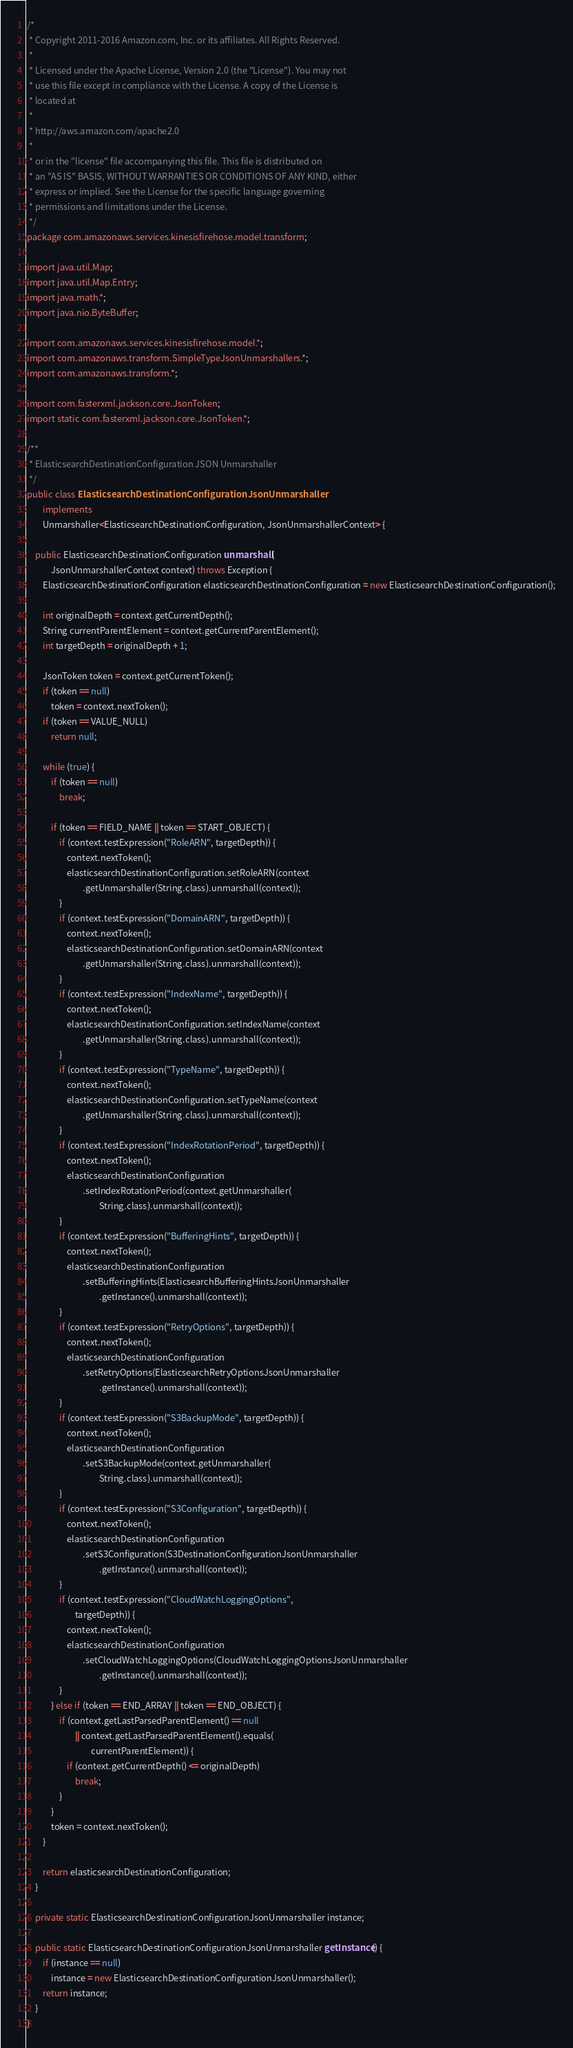Convert code to text. <code><loc_0><loc_0><loc_500><loc_500><_Java_>/*
 * Copyright 2011-2016 Amazon.com, Inc. or its affiliates. All Rights Reserved.
 * 
 * Licensed under the Apache License, Version 2.0 (the "License"). You may not
 * use this file except in compliance with the License. A copy of the License is
 * located at
 * 
 * http://aws.amazon.com/apache2.0
 * 
 * or in the "license" file accompanying this file. This file is distributed on
 * an "AS IS" BASIS, WITHOUT WARRANTIES OR CONDITIONS OF ANY KIND, either
 * express or implied. See the License for the specific language governing
 * permissions and limitations under the License.
 */
package com.amazonaws.services.kinesisfirehose.model.transform;

import java.util.Map;
import java.util.Map.Entry;
import java.math.*;
import java.nio.ByteBuffer;

import com.amazonaws.services.kinesisfirehose.model.*;
import com.amazonaws.transform.SimpleTypeJsonUnmarshallers.*;
import com.amazonaws.transform.*;

import com.fasterxml.jackson.core.JsonToken;
import static com.fasterxml.jackson.core.JsonToken.*;

/**
 * ElasticsearchDestinationConfiguration JSON Unmarshaller
 */
public class ElasticsearchDestinationConfigurationJsonUnmarshaller
        implements
        Unmarshaller<ElasticsearchDestinationConfiguration, JsonUnmarshallerContext> {

    public ElasticsearchDestinationConfiguration unmarshall(
            JsonUnmarshallerContext context) throws Exception {
        ElasticsearchDestinationConfiguration elasticsearchDestinationConfiguration = new ElasticsearchDestinationConfiguration();

        int originalDepth = context.getCurrentDepth();
        String currentParentElement = context.getCurrentParentElement();
        int targetDepth = originalDepth + 1;

        JsonToken token = context.getCurrentToken();
        if (token == null)
            token = context.nextToken();
        if (token == VALUE_NULL)
            return null;

        while (true) {
            if (token == null)
                break;

            if (token == FIELD_NAME || token == START_OBJECT) {
                if (context.testExpression("RoleARN", targetDepth)) {
                    context.nextToken();
                    elasticsearchDestinationConfiguration.setRoleARN(context
                            .getUnmarshaller(String.class).unmarshall(context));
                }
                if (context.testExpression("DomainARN", targetDepth)) {
                    context.nextToken();
                    elasticsearchDestinationConfiguration.setDomainARN(context
                            .getUnmarshaller(String.class).unmarshall(context));
                }
                if (context.testExpression("IndexName", targetDepth)) {
                    context.nextToken();
                    elasticsearchDestinationConfiguration.setIndexName(context
                            .getUnmarshaller(String.class).unmarshall(context));
                }
                if (context.testExpression("TypeName", targetDepth)) {
                    context.nextToken();
                    elasticsearchDestinationConfiguration.setTypeName(context
                            .getUnmarshaller(String.class).unmarshall(context));
                }
                if (context.testExpression("IndexRotationPeriod", targetDepth)) {
                    context.nextToken();
                    elasticsearchDestinationConfiguration
                            .setIndexRotationPeriod(context.getUnmarshaller(
                                    String.class).unmarshall(context));
                }
                if (context.testExpression("BufferingHints", targetDepth)) {
                    context.nextToken();
                    elasticsearchDestinationConfiguration
                            .setBufferingHints(ElasticsearchBufferingHintsJsonUnmarshaller
                                    .getInstance().unmarshall(context));
                }
                if (context.testExpression("RetryOptions", targetDepth)) {
                    context.nextToken();
                    elasticsearchDestinationConfiguration
                            .setRetryOptions(ElasticsearchRetryOptionsJsonUnmarshaller
                                    .getInstance().unmarshall(context));
                }
                if (context.testExpression("S3BackupMode", targetDepth)) {
                    context.nextToken();
                    elasticsearchDestinationConfiguration
                            .setS3BackupMode(context.getUnmarshaller(
                                    String.class).unmarshall(context));
                }
                if (context.testExpression("S3Configuration", targetDepth)) {
                    context.nextToken();
                    elasticsearchDestinationConfiguration
                            .setS3Configuration(S3DestinationConfigurationJsonUnmarshaller
                                    .getInstance().unmarshall(context));
                }
                if (context.testExpression("CloudWatchLoggingOptions",
                        targetDepth)) {
                    context.nextToken();
                    elasticsearchDestinationConfiguration
                            .setCloudWatchLoggingOptions(CloudWatchLoggingOptionsJsonUnmarshaller
                                    .getInstance().unmarshall(context));
                }
            } else if (token == END_ARRAY || token == END_OBJECT) {
                if (context.getLastParsedParentElement() == null
                        || context.getLastParsedParentElement().equals(
                                currentParentElement)) {
                    if (context.getCurrentDepth() <= originalDepth)
                        break;
                }
            }
            token = context.nextToken();
        }

        return elasticsearchDestinationConfiguration;
    }

    private static ElasticsearchDestinationConfigurationJsonUnmarshaller instance;

    public static ElasticsearchDestinationConfigurationJsonUnmarshaller getInstance() {
        if (instance == null)
            instance = new ElasticsearchDestinationConfigurationJsonUnmarshaller();
        return instance;
    }
}
</code> 